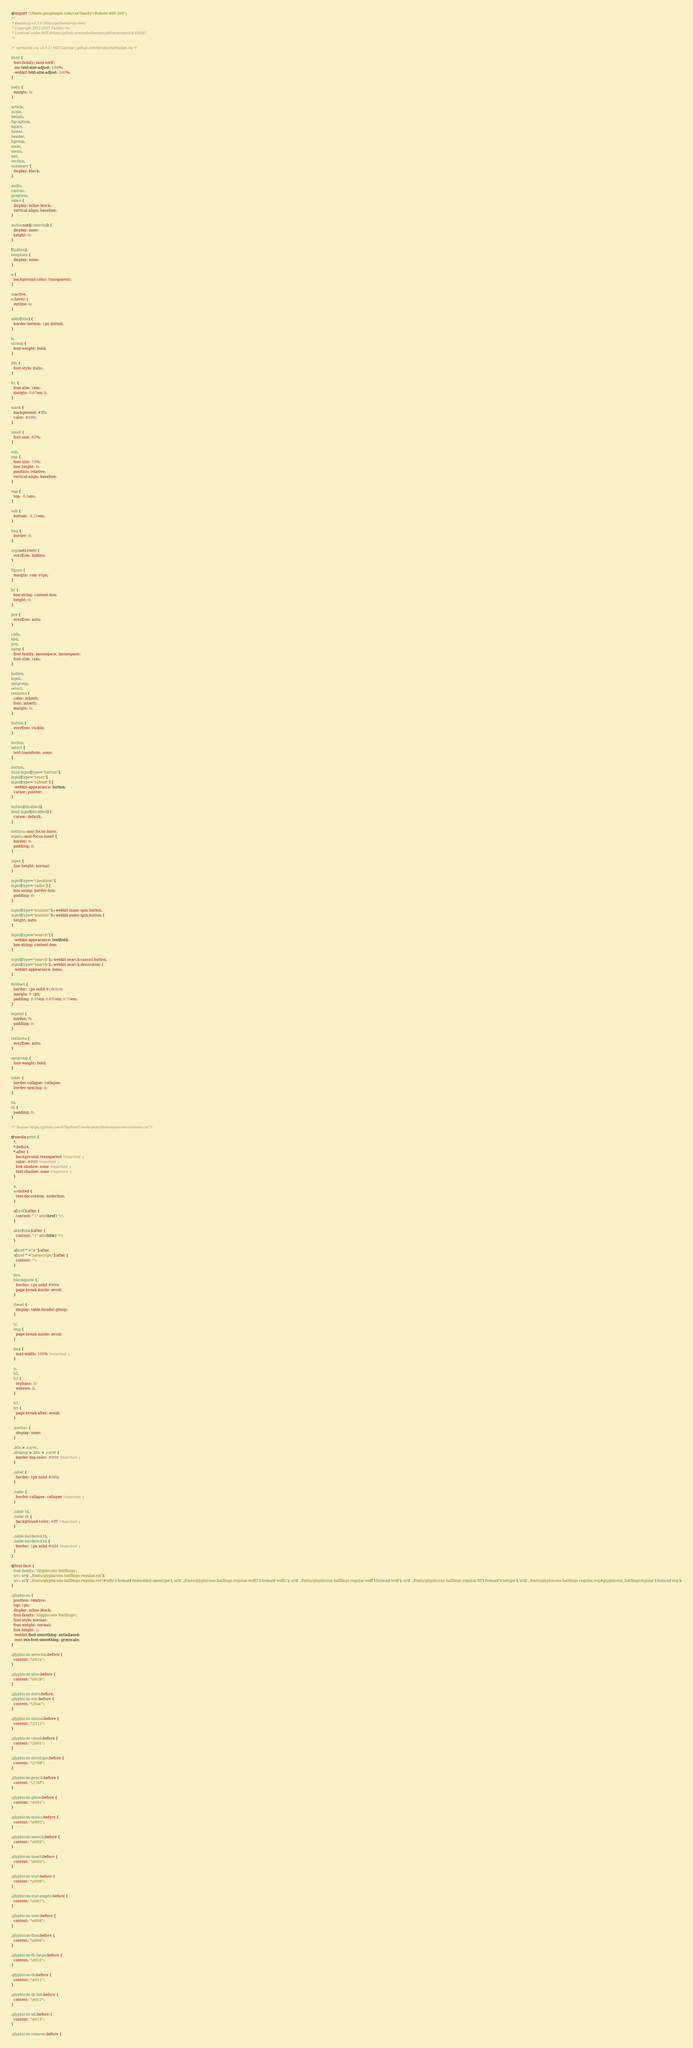Convert code to text. <code><loc_0><loc_0><loc_500><loc_500><_CSS_>@import "//fonts.googleapis.com/css?family=Roboto:400,300";
/*!
 * Bootstrap v3.3.6 (http://getbootstrap.com)
 * Copyright 2011-2015 Twitter, Inc.
 * Licensed under MIT (https://github.com/twbs/bootstrap/blob/master/LICENSE)
 */

/*! normalize.css v3.0.3 | MIT License | github.com/necolas/normalize.css */

html {
  font-family: sans-serif;
  -ms-text-size-adjust: 100%;
  -webkit-text-size-adjust: 100%;
}

body {
  margin: 0;
}

article,
aside,
details,
figcaption,
figure,
footer,
header,
hgroup,
main,
menu,
nav,
section,
summary {
  display: block;
}

audio,
canvas,
progress,
video {
  display: inline-block;
  vertical-align: baseline;
}

audio:not([controls]) {
  display: none;
  height: 0;
}

[hidden],
template {
  display: none;
}

a {
  background-color: transparent;
}

a:active,
a:hover {
  outline: 0;
}

abbr[title] {
  border-bottom: 1px dotted;
}

b,
strong {
  font-weight: bold;
}

dfn {
  font-style: italic;
}

h1 {
  font-size: 2em;
  margin: 0.67em 0;
}

mark {
  background: #ff0;
  color: #000;
}

small {
  font-size: 80%;
}

sub,
sup {
  font-size: 75%;
  line-height: 0;
  position: relative;
  vertical-align: baseline;
}

sup {
  top: -0.5em;
}

sub {
  bottom: -0.25em;
}

img {
  border: 0;
}

svg:not(:root) {
  overflow: hidden;
}

figure {
  margin: 1em 40px;
}

hr {
  box-sizing: content-box;
  height: 0;
}

pre {
  overflow: auto;
}

code,
kbd,
pre,
samp {
  font-family: monospace, monospace;
  font-size: 1em;
}

button,
input,
optgroup,
select,
textarea {
  color: inherit;
  font: inherit;
  margin: 0;
}

button {
  overflow: visible;
}

button,
select {
  text-transform: none;
}

button,
html input[type="button"],
input[type="reset"],
input[type="submit"] {
  -webkit-appearance: button;
  cursor: pointer;
}

button[disabled],
html input[disabled] {
  cursor: default;
}

button::-moz-focus-inner,
input::-moz-focus-inner {
  border: 0;
  padding: 0;
}

input {
  line-height: normal;
}

input[type="checkbox"],
input[type="radio"] {
  box-sizing: border-box;
  padding: 0;
}

input[type="number"]::-webkit-inner-spin-button,
input[type="number"]::-webkit-outer-spin-button {
  height: auto;
}

input[type="search"] {
  -webkit-appearance: textfield;
  box-sizing: content-box;
}

input[type="search"]::-webkit-search-cancel-button,
input[type="search"]::-webkit-search-decoration {
  -webkit-appearance: none;
}

fieldset {
  border: 1px solid #c0c0c0;
  margin: 0 2px;
  padding: 0.35em 0.625em 0.75em;
}

legend {
  border: 0;
  padding: 0;
}

textarea {
  overflow: auto;
}

optgroup {
  font-weight: bold;
}

table {
  border-collapse: collapse;
  border-spacing: 0;
}

td,
th {
  padding: 0;
}

/*! Source: https://github.com/h5bp/html5-boilerplate/blob/master/src/css/main.css */

@media print {
  *,
  *:before,
  *:after {
    background: transparent !important;
    color: #000 !important;
    box-shadow: none !important;
    text-shadow: none !important;
  }

  a,
  a:visited {
    text-decoration: underline;
  }

  a[href]:after {
    content: " (" attr(href) ")";
  }

  abbr[title]:after {
    content: " (" attr(title) ")";
  }

  a[href^="#"]:after,
  a[href^="javascript:"]:after {
    content: "";
  }

  pre,
  blockquote {
    border: 1px solid #999;
    page-break-inside: avoid;
  }

  thead {
    display: table-header-group;
  }

  tr,
  img {
    page-break-inside: avoid;
  }

  img {
    max-width: 100% !important;
  }

  p,
  h2,
  h3 {
    orphans: 3;
    widows: 3;
  }

  h2,
  h3 {
    page-break-after: avoid;
  }

  .navbar {
    display: none;
  }

  .btn > .caret,
  .dropup > .btn > .caret {
    border-top-color: #000 !important;
  }

  .label {
    border: 1px solid #000;
  }

  .table {
    border-collapse: collapse !important;
  }

  .table td,
  .table th {
    background-color: #fff !important;
  }

  .table-bordered th,
  .table-bordered td {
    border: 1px solid #ddd !important;
  }
}

@font-face {
  font-family: 'Glyphicons Halflings';
  src: url('../fonts/glyphicons-halflings-regular.eot');
  src: url('../fonts/glyphicons-halflings-regular.eot?#iefix') format('embedded-opentype'), url('../fonts/glyphicons-halflings-regular.woff2') format('woff2'), url('../fonts/glyphicons-halflings-regular.woff') format('woff'), url('../fonts/glyphicons-halflings-regular.ttf') format('truetype'), url('../fonts/glyphicons-halflings-regular.svg#glyphicons_halflingsregular') format('svg');
}

.glyphicon {
  position: relative;
  top: 1px;
  display: inline-block;
  font-family: 'Glyphicons Halflings';
  font-style: normal;
  font-weight: normal;
  line-height: 1;
  -webkit-font-smoothing: antialiased;
  -moz-osx-font-smoothing: grayscale;
}

.glyphicon-asterisk:before {
  content: "\002a";
}

.glyphicon-plus:before {
  content: "\002b";
}

.glyphicon-euro:before,
.glyphicon-eur:before {
  content: "\20ac";
}

.glyphicon-minus:before {
  content: "\2212";
}

.glyphicon-cloud:before {
  content: "\2601";
}

.glyphicon-envelope:before {
  content: "\2709";
}

.glyphicon-pencil:before {
  content: "\270f";
}

.glyphicon-glass:before {
  content: "\e001";
}

.glyphicon-music:before {
  content: "\e002";
}

.glyphicon-search:before {
  content: "\e003";
}

.glyphicon-heart:before {
  content: "\e005";
}

.glyphicon-star:before {
  content: "\e006";
}

.glyphicon-star-empty:before {
  content: "\e007";
}

.glyphicon-user:before {
  content: "\e008";
}

.glyphicon-film:before {
  content: "\e009";
}

.glyphicon-th-large:before {
  content: "\e010";
}

.glyphicon-th:before {
  content: "\e011";
}

.glyphicon-th-list:before {
  content: "\e012";
}

.glyphicon-ok:before {
  content: "\e013";
}

.glyphicon-remove:before {</code> 